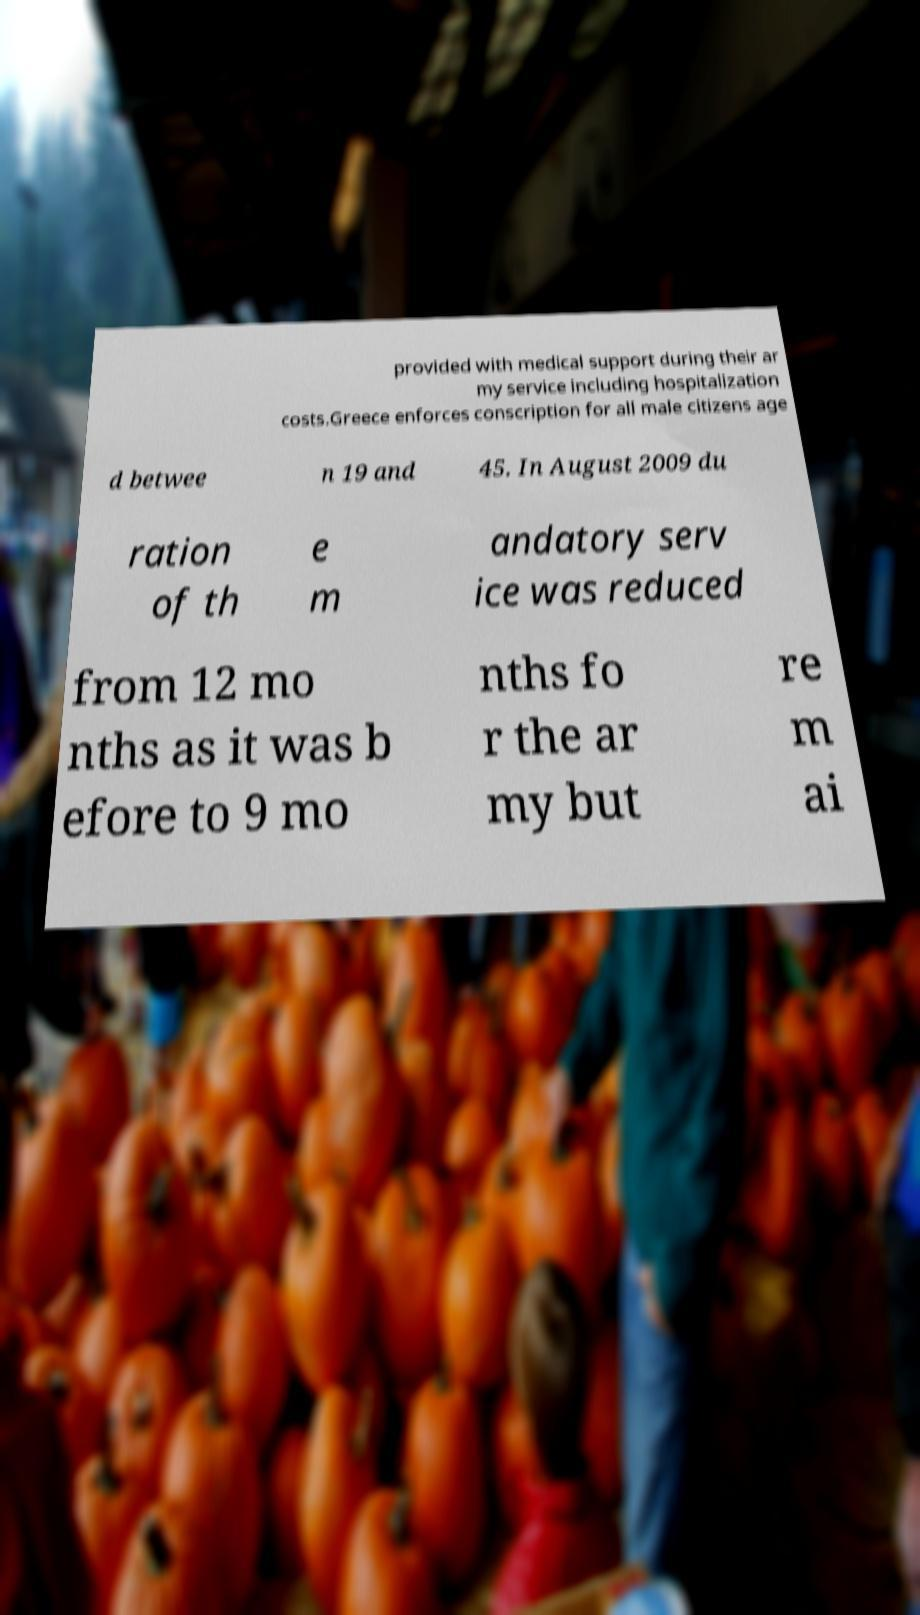Can you read and provide the text displayed in the image?This photo seems to have some interesting text. Can you extract and type it out for me? provided with medical support during their ar my service including hospitalization costs.Greece enforces conscription for all male citizens age d betwee n 19 and 45. In August 2009 du ration of th e m andatory serv ice was reduced from 12 mo nths as it was b efore to 9 mo nths fo r the ar my but re m ai 